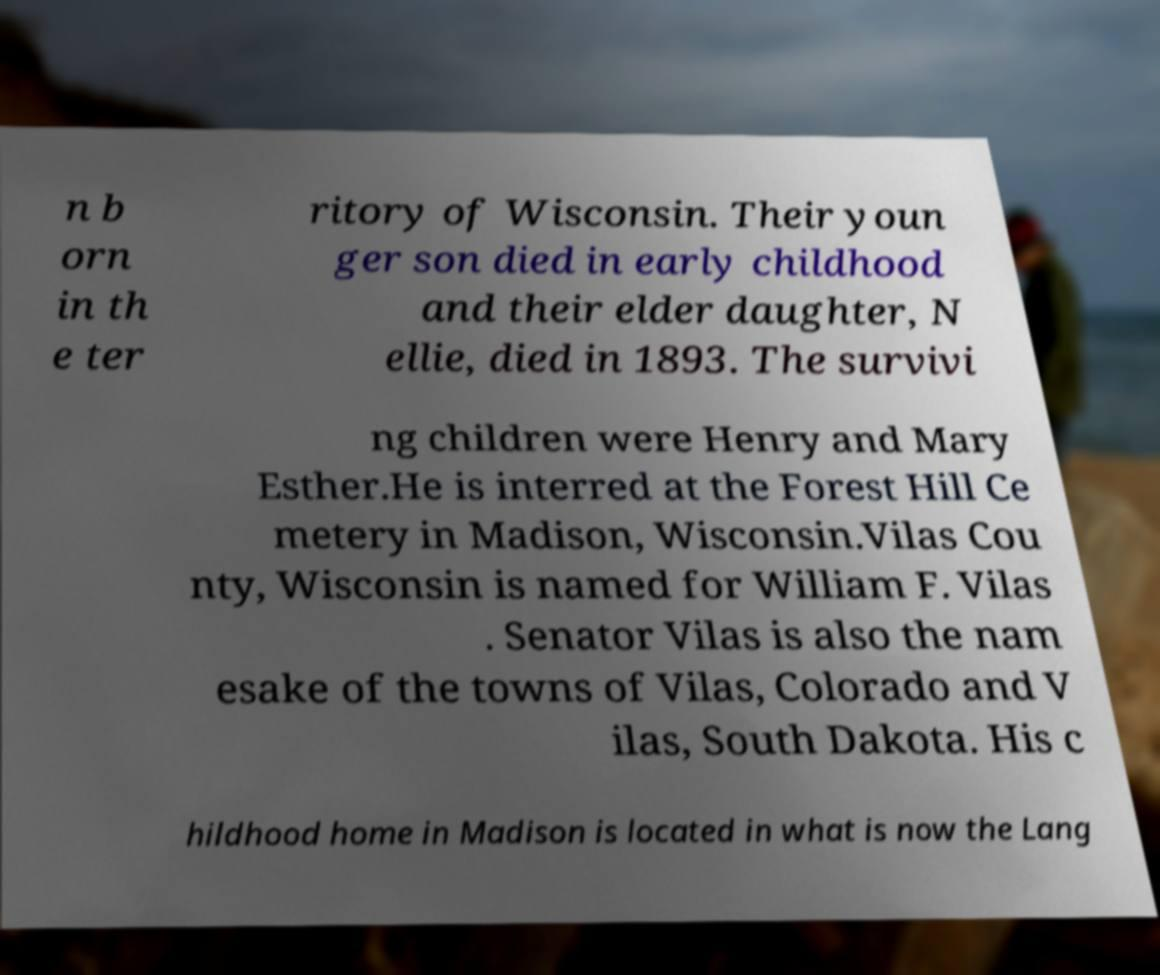Could you assist in decoding the text presented in this image and type it out clearly? n b orn in th e ter ritory of Wisconsin. Their youn ger son died in early childhood and their elder daughter, N ellie, died in 1893. The survivi ng children were Henry and Mary Esther.He is interred at the Forest Hill Ce metery in Madison, Wisconsin.Vilas Cou nty, Wisconsin is named for William F. Vilas . Senator Vilas is also the nam esake of the towns of Vilas, Colorado and V ilas, South Dakota. His c hildhood home in Madison is located in what is now the Lang 